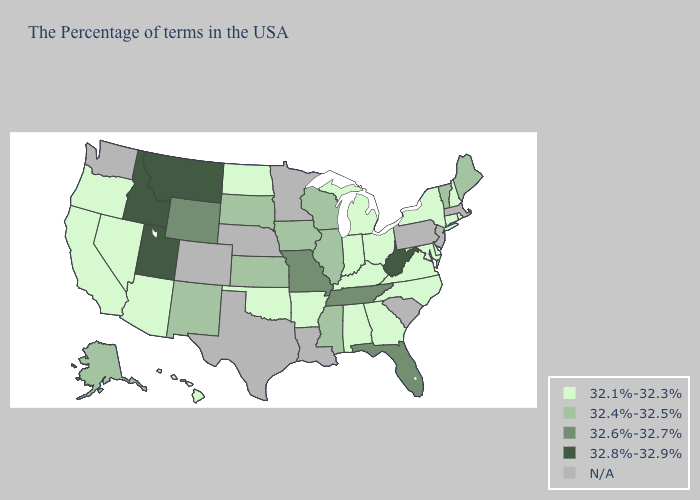What is the value of New Jersey?
Be succinct. N/A. Does Maine have the lowest value in the Northeast?
Concise answer only. No. Name the states that have a value in the range 32.8%-32.9%?
Keep it brief. West Virginia, Utah, Montana, Idaho. Which states hav the highest value in the Northeast?
Quick response, please. Maine, Vermont. Which states have the lowest value in the USA?
Answer briefly. Rhode Island, New Hampshire, Connecticut, New York, Delaware, Maryland, Virginia, North Carolina, Ohio, Georgia, Michigan, Kentucky, Indiana, Alabama, Arkansas, Oklahoma, North Dakota, Arizona, Nevada, California, Oregon, Hawaii. Does Illinois have the highest value in the MidWest?
Concise answer only. No. What is the lowest value in the South?
Keep it brief. 32.1%-32.3%. Among the states that border North Carolina , which have the lowest value?
Be succinct. Virginia, Georgia. Name the states that have a value in the range 32.1%-32.3%?
Answer briefly. Rhode Island, New Hampshire, Connecticut, New York, Delaware, Maryland, Virginia, North Carolina, Ohio, Georgia, Michigan, Kentucky, Indiana, Alabama, Arkansas, Oklahoma, North Dakota, Arizona, Nevada, California, Oregon, Hawaii. Which states have the lowest value in the USA?
Write a very short answer. Rhode Island, New Hampshire, Connecticut, New York, Delaware, Maryland, Virginia, North Carolina, Ohio, Georgia, Michigan, Kentucky, Indiana, Alabama, Arkansas, Oklahoma, North Dakota, Arizona, Nevada, California, Oregon, Hawaii. What is the value of Illinois?
Keep it brief. 32.4%-32.5%. 